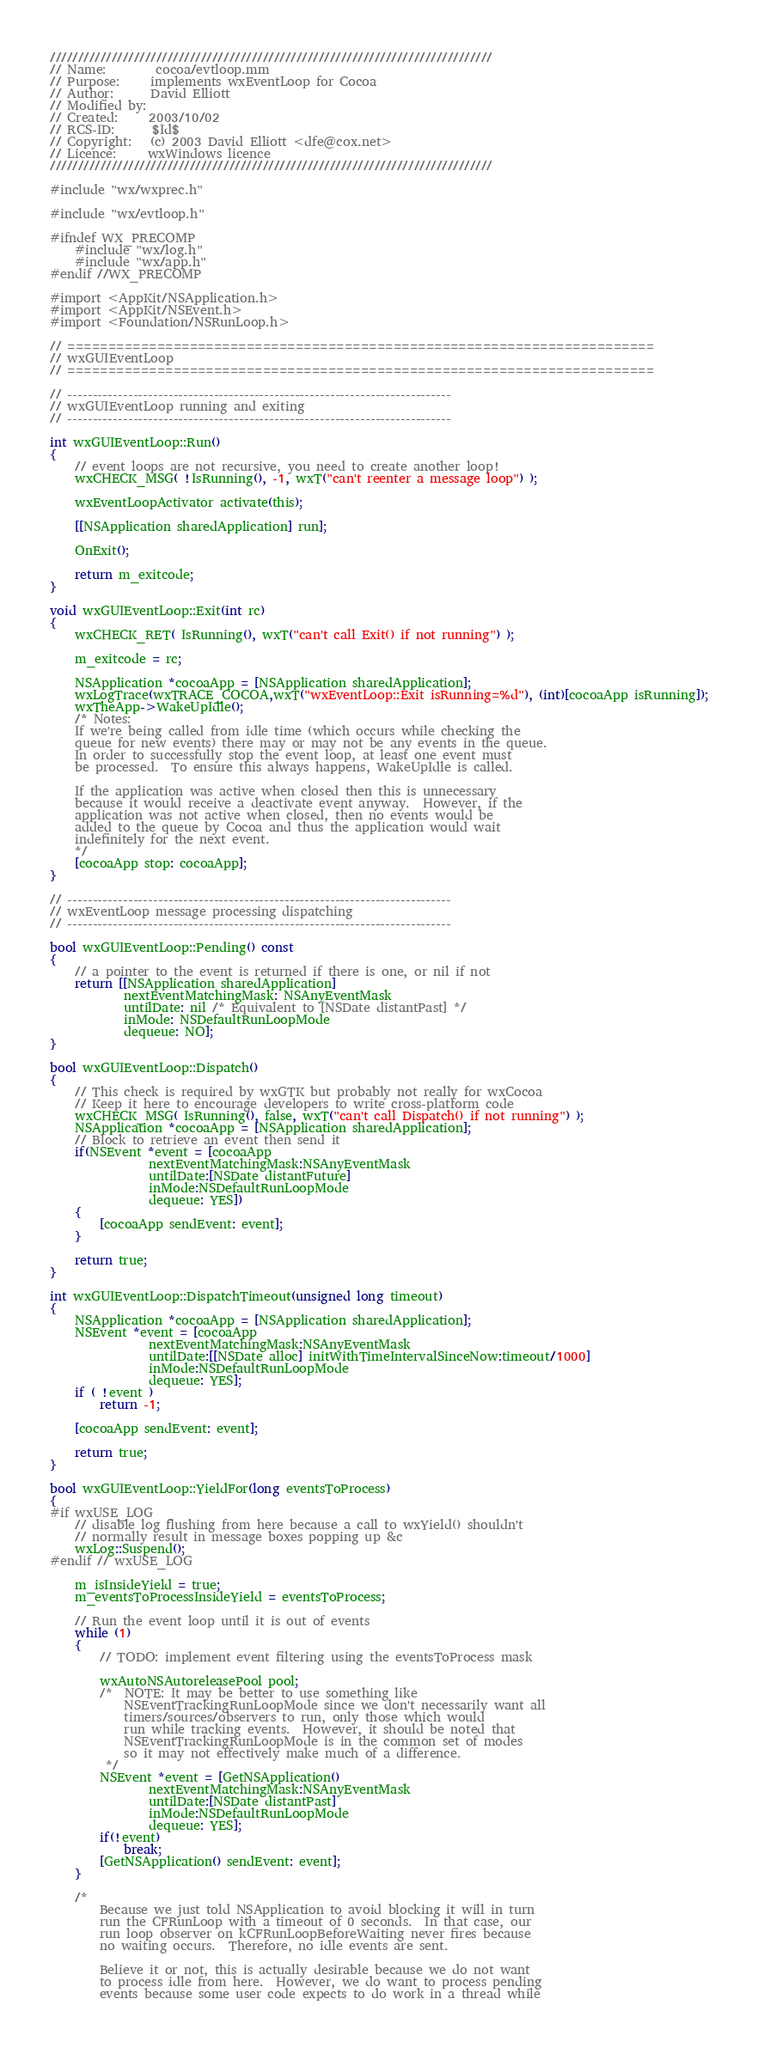Convert code to text. <code><loc_0><loc_0><loc_500><loc_500><_ObjectiveC_>///////////////////////////////////////////////////////////////////////////////
// Name:        cocoa/evtloop.mm
// Purpose:     implements wxEventLoop for Cocoa
// Author:      David Elliott
// Modified by:
// Created:     2003/10/02
// RCS-ID:      $Id$
// Copyright:   (c) 2003 David Elliott <dfe@cox.net>
// Licence:     wxWindows licence
///////////////////////////////////////////////////////////////////////////////

#include "wx/wxprec.h"

#include "wx/evtloop.h"

#ifndef WX_PRECOMP
    #include "wx/log.h"
    #include "wx/app.h"
#endif //WX_PRECOMP

#import <AppKit/NSApplication.h>
#import <AppKit/NSEvent.h>
#import <Foundation/NSRunLoop.h>

// ========================================================================
// wxGUIEventLoop
// ========================================================================

// ----------------------------------------------------------------------------
// wxGUIEventLoop running and exiting
// ----------------------------------------------------------------------------

int wxGUIEventLoop::Run()
{
    // event loops are not recursive, you need to create another loop!
    wxCHECK_MSG( !IsRunning(), -1, wxT("can't reenter a message loop") );

    wxEventLoopActivator activate(this);

    [[NSApplication sharedApplication] run];

    OnExit();

    return m_exitcode;
}

void wxGUIEventLoop::Exit(int rc)
{
    wxCHECK_RET( IsRunning(), wxT("can't call Exit() if not running") );

    m_exitcode = rc;

    NSApplication *cocoaApp = [NSApplication sharedApplication];
    wxLogTrace(wxTRACE_COCOA,wxT("wxEventLoop::Exit isRunning=%d"), (int)[cocoaApp isRunning]);
    wxTheApp->WakeUpIdle();
    /* Notes:
    If we're being called from idle time (which occurs while checking the
    queue for new events) there may or may not be any events in the queue.
    In order to successfully stop the event loop, at least one event must
    be processed.  To ensure this always happens, WakeUpIdle is called.

    If the application was active when closed then this is unnecessary
    because it would receive a deactivate event anyway.  However, if the
    application was not active when closed, then no events would be
    added to the queue by Cocoa and thus the application would wait
    indefinitely for the next event.
    */
    [cocoaApp stop: cocoaApp];
}

// ----------------------------------------------------------------------------
// wxEventLoop message processing dispatching
// ----------------------------------------------------------------------------

bool wxGUIEventLoop::Pending() const
{
    // a pointer to the event is returned if there is one, or nil if not
    return [[NSApplication sharedApplication]
            nextEventMatchingMask: NSAnyEventMask
            untilDate: nil /* Equivalent to [NSDate distantPast] */
            inMode: NSDefaultRunLoopMode
            dequeue: NO];
}

bool wxGUIEventLoop::Dispatch()
{
    // This check is required by wxGTK but probably not really for wxCocoa
    // Keep it here to encourage developers to write cross-platform code
    wxCHECK_MSG( IsRunning(), false, wxT("can't call Dispatch() if not running") );
    NSApplication *cocoaApp = [NSApplication sharedApplication];
    // Block to retrieve an event then send it
    if(NSEvent *event = [cocoaApp
                nextEventMatchingMask:NSAnyEventMask
                untilDate:[NSDate distantFuture]
                inMode:NSDefaultRunLoopMode
                dequeue: YES])
    {
        [cocoaApp sendEvent: event];
    }

    return true;
}

int wxGUIEventLoop::DispatchTimeout(unsigned long timeout)
{
    NSApplication *cocoaApp = [NSApplication sharedApplication];
    NSEvent *event = [cocoaApp
                nextEventMatchingMask:NSAnyEventMask
                untilDate:[[NSDate alloc] initWithTimeIntervalSinceNow:timeout/1000]
                inMode:NSDefaultRunLoopMode
                dequeue: YES];
    if ( !event )
        return -1;

    [cocoaApp sendEvent: event];

    return true;
}

bool wxGUIEventLoop::YieldFor(long eventsToProcess)
{
#if wxUSE_LOG
    // disable log flushing from here because a call to wxYield() shouldn't
    // normally result in message boxes popping up &c
    wxLog::Suspend();
#endif // wxUSE_LOG

    m_isInsideYield = true;
    m_eventsToProcessInsideYield = eventsToProcess;

    // Run the event loop until it is out of events
    while (1)
    {
        // TODO: implement event filtering using the eventsToProcess mask

        wxAutoNSAutoreleasePool pool;
        /*  NOTE: It may be better to use something like
            NSEventTrackingRunLoopMode since we don't necessarily want all
            timers/sources/observers to run, only those which would
            run while tracking events.  However, it should be noted that
            NSEventTrackingRunLoopMode is in the common set of modes
            so it may not effectively make much of a difference.
         */
        NSEvent *event = [GetNSApplication()
                nextEventMatchingMask:NSAnyEventMask
                untilDate:[NSDate distantPast]
                inMode:NSDefaultRunLoopMode
                dequeue: YES];
        if(!event)
            break;
        [GetNSApplication() sendEvent: event];
    }

    /*
        Because we just told NSApplication to avoid blocking it will in turn
        run the CFRunLoop with a timeout of 0 seconds.  In that case, our
        run loop observer on kCFRunLoopBeforeWaiting never fires because
        no waiting occurs.  Therefore, no idle events are sent.

        Believe it or not, this is actually desirable because we do not want
        to process idle from here.  However, we do want to process pending
        events because some user code expects to do work in a thread while</code> 